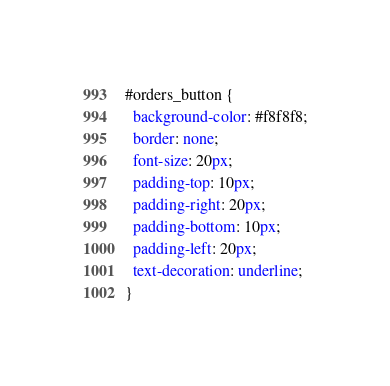Convert code to text. <code><loc_0><loc_0><loc_500><loc_500><_CSS_>#orders_button {
  background-color: #f8f8f8;
  border: none;  
  font-size: 20px;
  padding-top: 10px;
  padding-right: 20px;
  padding-bottom: 10px;
  padding-left: 20px;
  text-decoration: underline;
}
</code> 